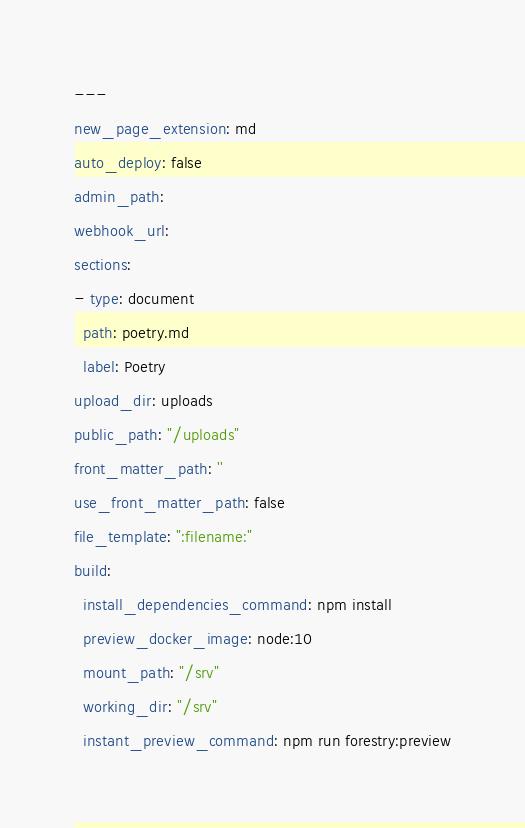<code> <loc_0><loc_0><loc_500><loc_500><_YAML_>---
new_page_extension: md
auto_deploy: false
admin_path: 
webhook_url: 
sections:
- type: document
  path: poetry.md
  label: Poetry
upload_dir: uploads
public_path: "/uploads"
front_matter_path: ''
use_front_matter_path: false
file_template: ":filename:"
build:
  install_dependencies_command: npm install
  preview_docker_image: node:10
  mount_path: "/srv"
  working_dir: "/srv"
  instant_preview_command: npm run forestry:preview
</code> 